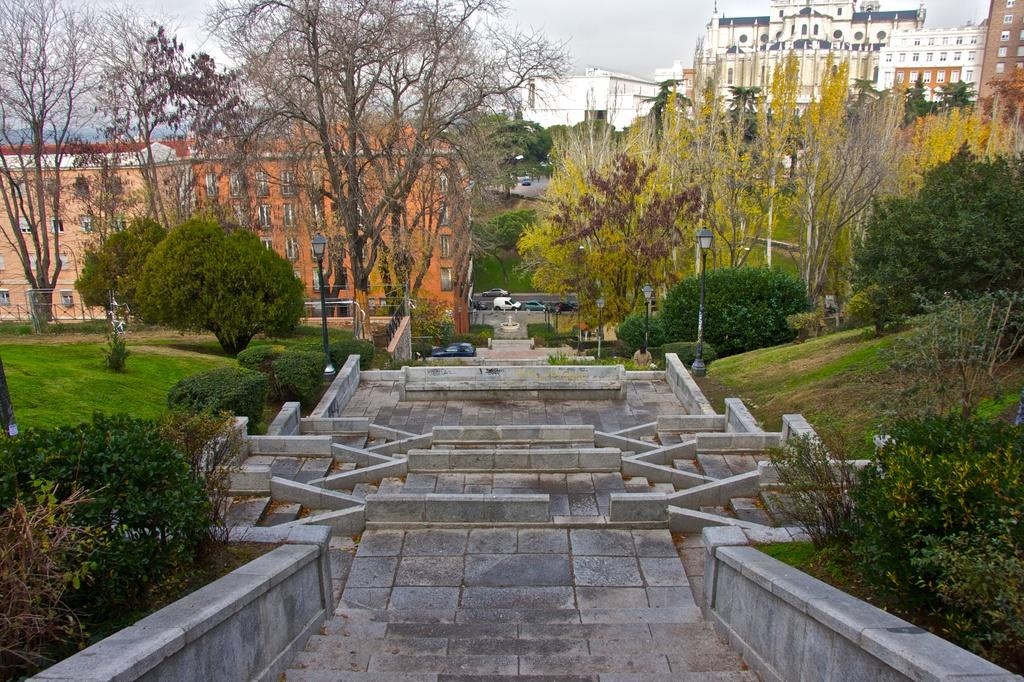What is located in the middle of the image? There are stairs in the middle of the image. What can be seen behind the stairs? There is a group of trees and buildings visible behind the stairs. What type of vegetation is beside the stairs? There are plants beside the stairs. What type of furniture is visible on the stairs in the image? There is no furniture visible on the stairs in the image. Can you describe the button detail on the trees in the image? There are no buttons or button details present on the trees in the image. 